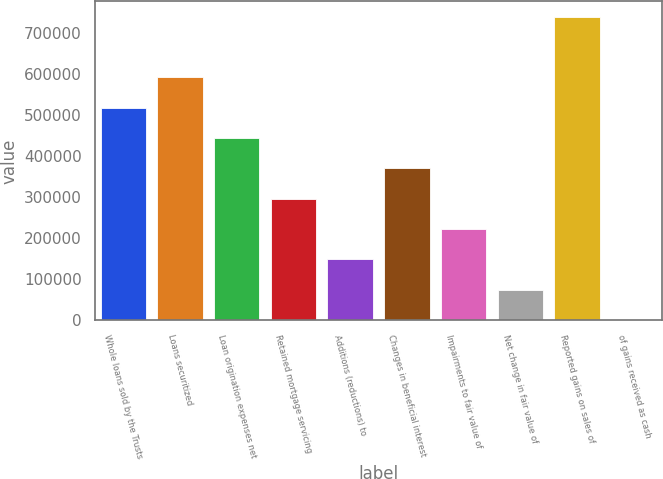Convert chart. <chart><loc_0><loc_0><loc_500><loc_500><bar_chart><fcel>Whole loans sold by the Trusts<fcel>Loans securitized<fcel>Loan origination expenses net<fcel>Retained mortgage servicing<fcel>Additions (reductions) to<fcel>Changes in beneficial interest<fcel>Impairments to fair value of<fcel>Net change in fair value of<fcel>Reported gains on sales of<fcel>of gains received as cash<nl><fcel>518267<fcel>592292<fcel>444242<fcel>296191<fcel>148141<fcel>370216<fcel>222166<fcel>74115.3<fcel>740343<fcel>90<nl></chart> 